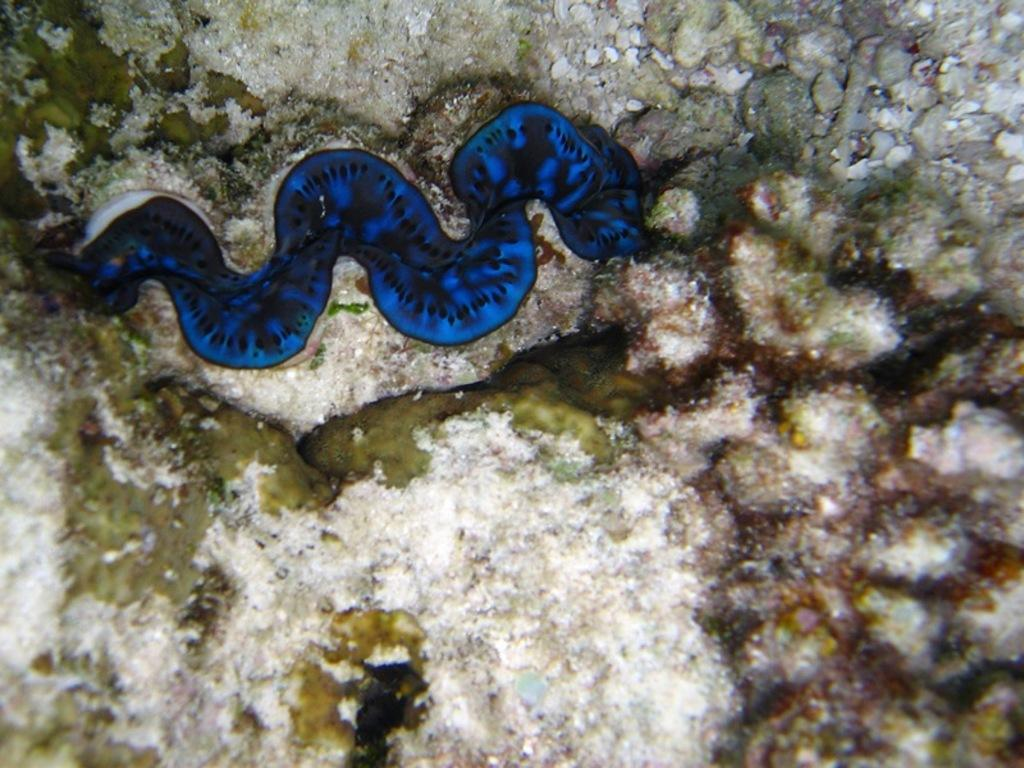What is the main subject in the foreground of the image? There is a snake fish in the foreground of the image. Can you describe the setting or location of the image? The image may have been taken in the ocean. What is the current hour according to the amusement park clock in the image? There is no amusement park clock present in the image, as it features a snake fish in the ocean. 